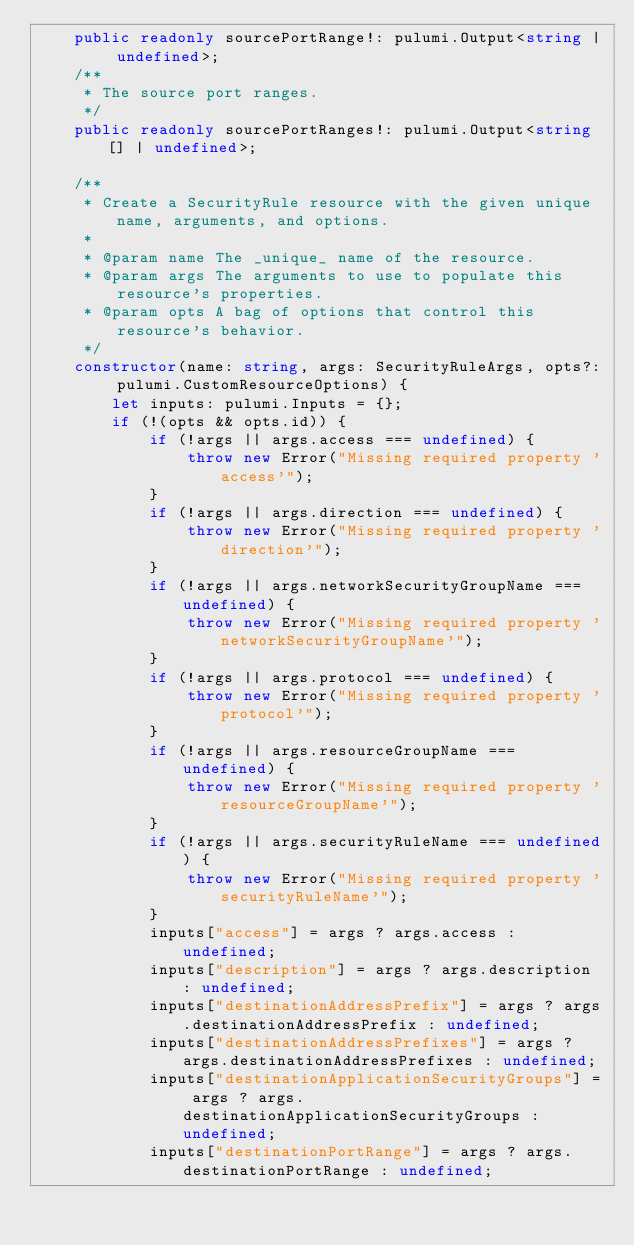Convert code to text. <code><loc_0><loc_0><loc_500><loc_500><_TypeScript_>    public readonly sourcePortRange!: pulumi.Output<string | undefined>;
    /**
     * The source port ranges.
     */
    public readonly sourcePortRanges!: pulumi.Output<string[] | undefined>;

    /**
     * Create a SecurityRule resource with the given unique name, arguments, and options.
     *
     * @param name The _unique_ name of the resource.
     * @param args The arguments to use to populate this resource's properties.
     * @param opts A bag of options that control this resource's behavior.
     */
    constructor(name: string, args: SecurityRuleArgs, opts?: pulumi.CustomResourceOptions) {
        let inputs: pulumi.Inputs = {};
        if (!(opts && opts.id)) {
            if (!args || args.access === undefined) {
                throw new Error("Missing required property 'access'");
            }
            if (!args || args.direction === undefined) {
                throw new Error("Missing required property 'direction'");
            }
            if (!args || args.networkSecurityGroupName === undefined) {
                throw new Error("Missing required property 'networkSecurityGroupName'");
            }
            if (!args || args.protocol === undefined) {
                throw new Error("Missing required property 'protocol'");
            }
            if (!args || args.resourceGroupName === undefined) {
                throw new Error("Missing required property 'resourceGroupName'");
            }
            if (!args || args.securityRuleName === undefined) {
                throw new Error("Missing required property 'securityRuleName'");
            }
            inputs["access"] = args ? args.access : undefined;
            inputs["description"] = args ? args.description : undefined;
            inputs["destinationAddressPrefix"] = args ? args.destinationAddressPrefix : undefined;
            inputs["destinationAddressPrefixes"] = args ? args.destinationAddressPrefixes : undefined;
            inputs["destinationApplicationSecurityGroups"] = args ? args.destinationApplicationSecurityGroups : undefined;
            inputs["destinationPortRange"] = args ? args.destinationPortRange : undefined;</code> 